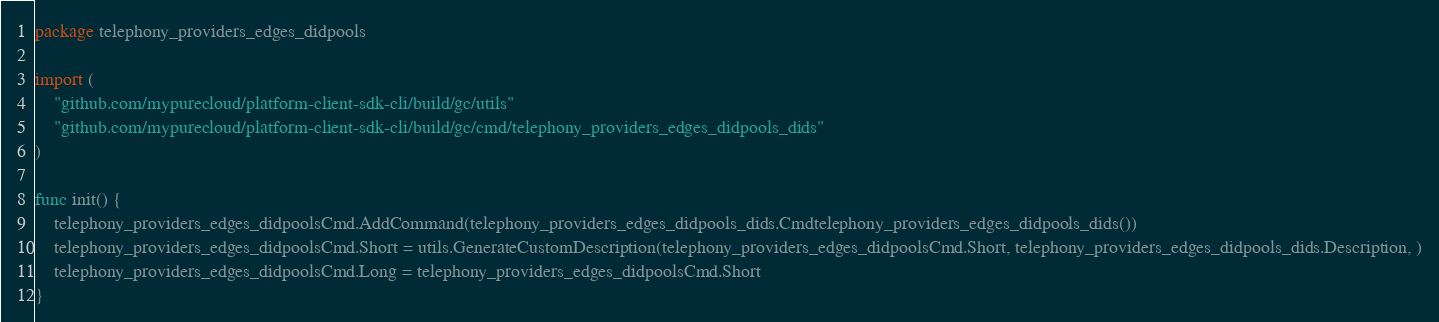Convert code to text. <code><loc_0><loc_0><loc_500><loc_500><_Go_>package telephony_providers_edges_didpools

import (
	"github.com/mypurecloud/platform-client-sdk-cli/build/gc/utils"
	"github.com/mypurecloud/platform-client-sdk-cli/build/gc/cmd/telephony_providers_edges_didpools_dids"
)

func init() {
	telephony_providers_edges_didpoolsCmd.AddCommand(telephony_providers_edges_didpools_dids.Cmdtelephony_providers_edges_didpools_dids())
	telephony_providers_edges_didpoolsCmd.Short = utils.GenerateCustomDescription(telephony_providers_edges_didpoolsCmd.Short, telephony_providers_edges_didpools_dids.Description, )
	telephony_providers_edges_didpoolsCmd.Long = telephony_providers_edges_didpoolsCmd.Short
}
</code> 